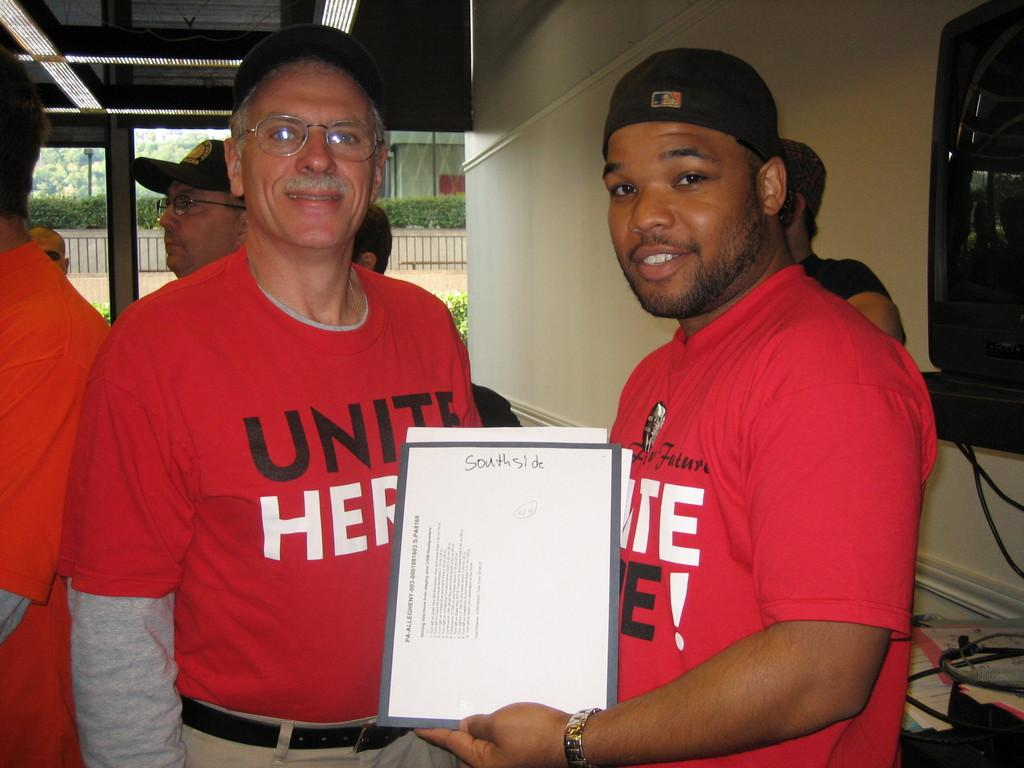Provide a one-sentence caption for the provided image. A man in a red shirt holds up a paper that has the words south side on the top. 